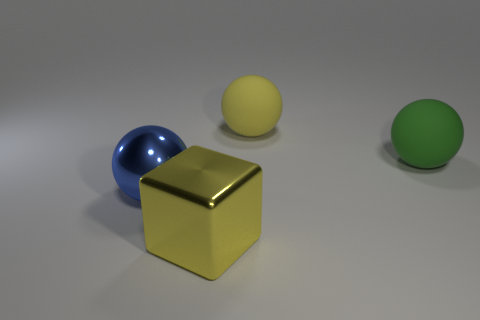What is the shape of the thing that is on the left side of the yellow ball and right of the blue sphere?
Provide a succinct answer. Cube. The thing that is both to the left of the big yellow matte object and behind the large yellow metallic cube is made of what material?
Give a very brief answer. Metal. The big yellow object that is the same material as the blue thing is what shape?
Make the answer very short. Cube. Is there any other thing of the same color as the big metal cube?
Your answer should be compact. Yes. Is the number of blue metallic things that are to the left of the green matte thing greater than the number of gray blocks?
Provide a short and direct response. Yes. What material is the large blue object?
Offer a terse response. Metal. What number of yellow things have the same size as the metallic block?
Your answer should be compact. 1. Is the number of big green balls behind the green rubber sphere the same as the number of big yellow balls that are left of the large yellow metal object?
Ensure brevity in your answer.  Yes. Do the blue thing and the yellow cube have the same material?
Offer a terse response. Yes. There is a shiny object that is behind the yellow metallic object; is there a thing that is behind it?
Provide a succinct answer. Yes. 